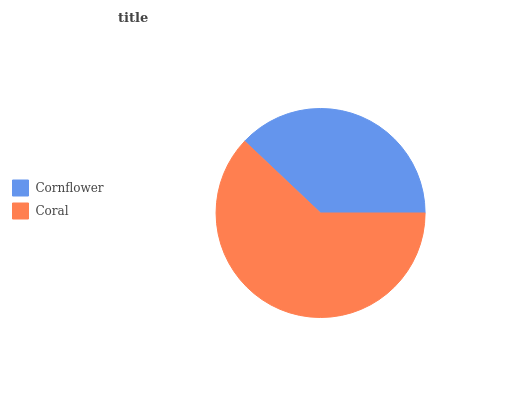Is Cornflower the minimum?
Answer yes or no. Yes. Is Coral the maximum?
Answer yes or no. Yes. Is Coral the minimum?
Answer yes or no. No. Is Coral greater than Cornflower?
Answer yes or no. Yes. Is Cornflower less than Coral?
Answer yes or no. Yes. Is Cornflower greater than Coral?
Answer yes or no. No. Is Coral less than Cornflower?
Answer yes or no. No. Is Coral the high median?
Answer yes or no. Yes. Is Cornflower the low median?
Answer yes or no. Yes. Is Cornflower the high median?
Answer yes or no. No. Is Coral the low median?
Answer yes or no. No. 